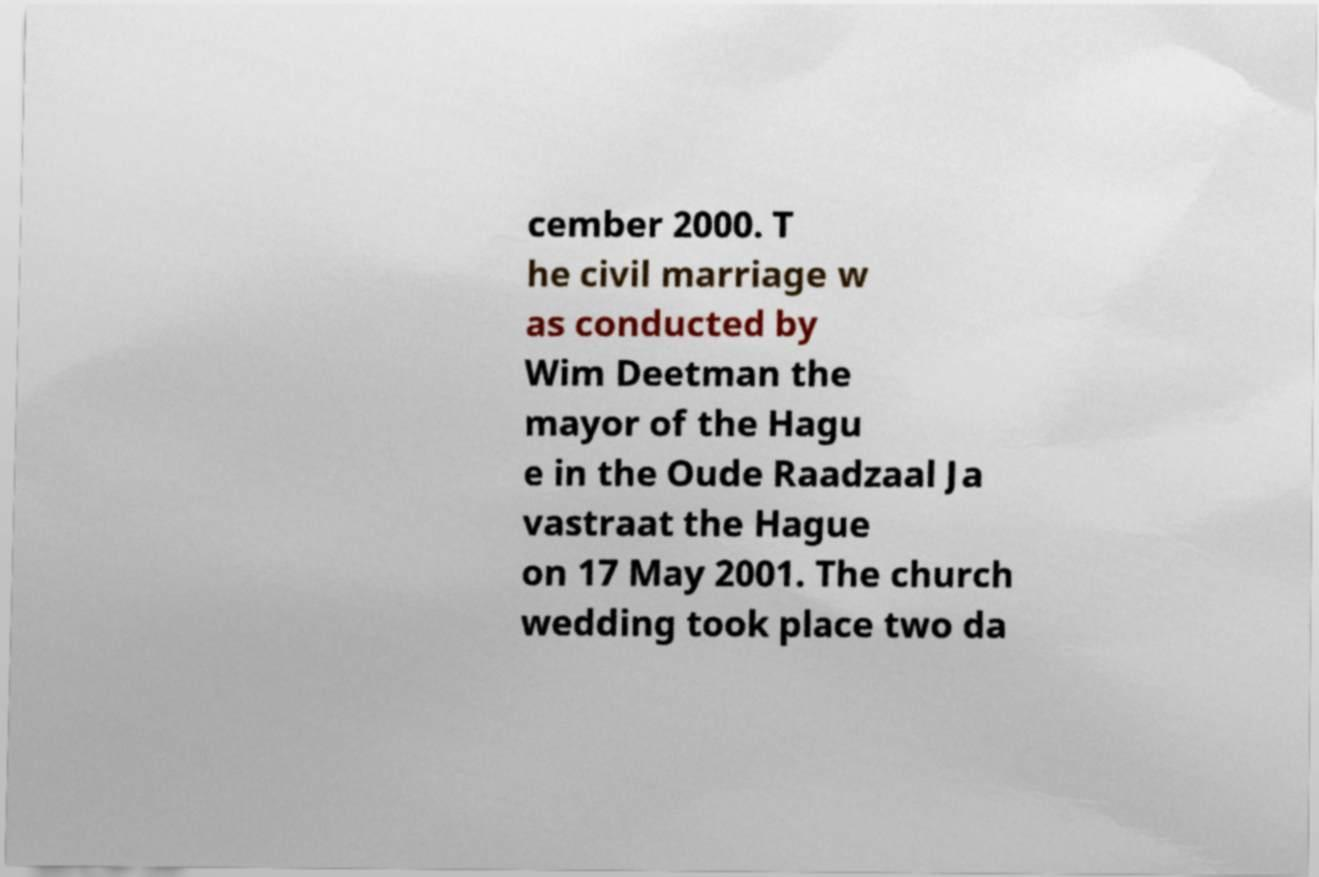Please read and relay the text visible in this image. What does it say? cember 2000. T he civil marriage w as conducted by Wim Deetman the mayor of the Hagu e in the Oude Raadzaal Ja vastraat the Hague on 17 May 2001. The church wedding took place two da 